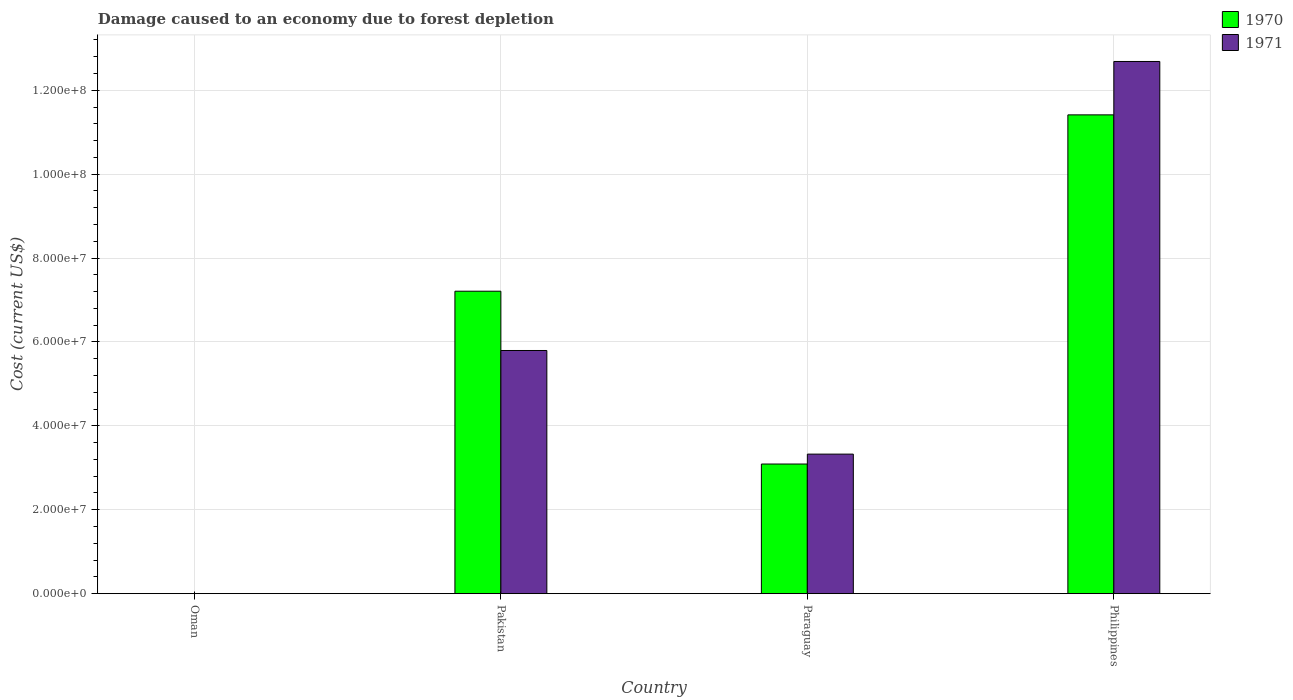Are the number of bars per tick equal to the number of legend labels?
Your answer should be compact. Yes. Are the number of bars on each tick of the X-axis equal?
Make the answer very short. Yes. What is the cost of damage caused due to forest depletion in 1970 in Pakistan?
Offer a very short reply. 7.21e+07. Across all countries, what is the maximum cost of damage caused due to forest depletion in 1970?
Keep it short and to the point. 1.14e+08. Across all countries, what is the minimum cost of damage caused due to forest depletion in 1971?
Offer a very short reply. 2.65e+04. In which country was the cost of damage caused due to forest depletion in 1971 maximum?
Offer a very short reply. Philippines. In which country was the cost of damage caused due to forest depletion in 1970 minimum?
Your answer should be compact. Oman. What is the total cost of damage caused due to forest depletion in 1970 in the graph?
Ensure brevity in your answer.  2.17e+08. What is the difference between the cost of damage caused due to forest depletion in 1971 in Pakistan and that in Paraguay?
Offer a terse response. 2.47e+07. What is the difference between the cost of damage caused due to forest depletion in 1970 in Pakistan and the cost of damage caused due to forest depletion in 1971 in Philippines?
Your response must be concise. -5.48e+07. What is the average cost of damage caused due to forest depletion in 1970 per country?
Give a very brief answer. 5.43e+07. What is the difference between the cost of damage caused due to forest depletion of/in 1970 and cost of damage caused due to forest depletion of/in 1971 in Oman?
Your answer should be very brief. 6781.75. What is the ratio of the cost of damage caused due to forest depletion in 1970 in Paraguay to that in Philippines?
Your answer should be very brief. 0.27. Is the cost of damage caused due to forest depletion in 1971 in Pakistan less than that in Paraguay?
Give a very brief answer. No. What is the difference between the highest and the second highest cost of damage caused due to forest depletion in 1971?
Your answer should be very brief. -2.47e+07. What is the difference between the highest and the lowest cost of damage caused due to forest depletion in 1970?
Offer a terse response. 1.14e+08. In how many countries, is the cost of damage caused due to forest depletion in 1970 greater than the average cost of damage caused due to forest depletion in 1970 taken over all countries?
Provide a short and direct response. 2. What does the 2nd bar from the left in Pakistan represents?
Your answer should be compact. 1971. What is the difference between two consecutive major ticks on the Y-axis?
Make the answer very short. 2.00e+07. Are the values on the major ticks of Y-axis written in scientific E-notation?
Provide a succinct answer. Yes. What is the title of the graph?
Make the answer very short. Damage caused to an economy due to forest depletion. What is the label or title of the X-axis?
Provide a short and direct response. Country. What is the label or title of the Y-axis?
Ensure brevity in your answer.  Cost (current US$). What is the Cost (current US$) of 1970 in Oman?
Your response must be concise. 3.33e+04. What is the Cost (current US$) of 1971 in Oman?
Your response must be concise. 2.65e+04. What is the Cost (current US$) of 1970 in Pakistan?
Make the answer very short. 7.21e+07. What is the Cost (current US$) of 1971 in Pakistan?
Ensure brevity in your answer.  5.80e+07. What is the Cost (current US$) of 1970 in Paraguay?
Provide a succinct answer. 3.09e+07. What is the Cost (current US$) in 1971 in Paraguay?
Provide a short and direct response. 3.33e+07. What is the Cost (current US$) in 1970 in Philippines?
Provide a succinct answer. 1.14e+08. What is the Cost (current US$) in 1971 in Philippines?
Keep it short and to the point. 1.27e+08. Across all countries, what is the maximum Cost (current US$) in 1970?
Offer a terse response. 1.14e+08. Across all countries, what is the maximum Cost (current US$) in 1971?
Provide a short and direct response. 1.27e+08. Across all countries, what is the minimum Cost (current US$) in 1970?
Ensure brevity in your answer.  3.33e+04. Across all countries, what is the minimum Cost (current US$) of 1971?
Keep it short and to the point. 2.65e+04. What is the total Cost (current US$) in 1970 in the graph?
Your response must be concise. 2.17e+08. What is the total Cost (current US$) of 1971 in the graph?
Your response must be concise. 2.18e+08. What is the difference between the Cost (current US$) in 1970 in Oman and that in Pakistan?
Offer a terse response. -7.21e+07. What is the difference between the Cost (current US$) in 1971 in Oman and that in Pakistan?
Your answer should be compact. -5.79e+07. What is the difference between the Cost (current US$) of 1970 in Oman and that in Paraguay?
Your answer should be very brief. -3.09e+07. What is the difference between the Cost (current US$) in 1971 in Oman and that in Paraguay?
Give a very brief answer. -3.32e+07. What is the difference between the Cost (current US$) of 1970 in Oman and that in Philippines?
Your answer should be compact. -1.14e+08. What is the difference between the Cost (current US$) in 1971 in Oman and that in Philippines?
Make the answer very short. -1.27e+08. What is the difference between the Cost (current US$) in 1970 in Pakistan and that in Paraguay?
Your answer should be compact. 4.12e+07. What is the difference between the Cost (current US$) in 1971 in Pakistan and that in Paraguay?
Ensure brevity in your answer.  2.47e+07. What is the difference between the Cost (current US$) of 1970 in Pakistan and that in Philippines?
Provide a succinct answer. -4.20e+07. What is the difference between the Cost (current US$) in 1971 in Pakistan and that in Philippines?
Your response must be concise. -6.89e+07. What is the difference between the Cost (current US$) of 1970 in Paraguay and that in Philippines?
Your answer should be very brief. -8.32e+07. What is the difference between the Cost (current US$) of 1971 in Paraguay and that in Philippines?
Make the answer very short. -9.36e+07. What is the difference between the Cost (current US$) of 1970 in Oman and the Cost (current US$) of 1971 in Pakistan?
Offer a terse response. -5.79e+07. What is the difference between the Cost (current US$) in 1970 in Oman and the Cost (current US$) in 1971 in Paraguay?
Provide a short and direct response. -3.32e+07. What is the difference between the Cost (current US$) in 1970 in Oman and the Cost (current US$) in 1971 in Philippines?
Offer a terse response. -1.27e+08. What is the difference between the Cost (current US$) of 1970 in Pakistan and the Cost (current US$) of 1971 in Paraguay?
Ensure brevity in your answer.  3.88e+07. What is the difference between the Cost (current US$) in 1970 in Pakistan and the Cost (current US$) in 1971 in Philippines?
Provide a succinct answer. -5.48e+07. What is the difference between the Cost (current US$) of 1970 in Paraguay and the Cost (current US$) of 1971 in Philippines?
Ensure brevity in your answer.  -9.60e+07. What is the average Cost (current US$) in 1970 per country?
Keep it short and to the point. 5.43e+07. What is the average Cost (current US$) of 1971 per country?
Your answer should be compact. 5.45e+07. What is the difference between the Cost (current US$) in 1970 and Cost (current US$) in 1971 in Oman?
Offer a terse response. 6781.75. What is the difference between the Cost (current US$) of 1970 and Cost (current US$) of 1971 in Pakistan?
Offer a very short reply. 1.41e+07. What is the difference between the Cost (current US$) of 1970 and Cost (current US$) of 1971 in Paraguay?
Make the answer very short. -2.36e+06. What is the difference between the Cost (current US$) in 1970 and Cost (current US$) in 1971 in Philippines?
Give a very brief answer. -1.27e+07. What is the ratio of the Cost (current US$) of 1971 in Oman to that in Pakistan?
Keep it short and to the point. 0. What is the ratio of the Cost (current US$) of 1970 in Oman to that in Paraguay?
Ensure brevity in your answer.  0. What is the ratio of the Cost (current US$) of 1971 in Oman to that in Paraguay?
Your response must be concise. 0. What is the ratio of the Cost (current US$) in 1971 in Oman to that in Philippines?
Your answer should be very brief. 0. What is the ratio of the Cost (current US$) in 1970 in Pakistan to that in Paraguay?
Your answer should be very brief. 2.33. What is the ratio of the Cost (current US$) of 1971 in Pakistan to that in Paraguay?
Provide a succinct answer. 1.74. What is the ratio of the Cost (current US$) in 1970 in Pakistan to that in Philippines?
Your response must be concise. 0.63. What is the ratio of the Cost (current US$) in 1971 in Pakistan to that in Philippines?
Offer a terse response. 0.46. What is the ratio of the Cost (current US$) of 1970 in Paraguay to that in Philippines?
Offer a terse response. 0.27. What is the ratio of the Cost (current US$) in 1971 in Paraguay to that in Philippines?
Provide a short and direct response. 0.26. What is the difference between the highest and the second highest Cost (current US$) of 1970?
Offer a very short reply. 4.20e+07. What is the difference between the highest and the second highest Cost (current US$) of 1971?
Make the answer very short. 6.89e+07. What is the difference between the highest and the lowest Cost (current US$) of 1970?
Provide a succinct answer. 1.14e+08. What is the difference between the highest and the lowest Cost (current US$) in 1971?
Provide a succinct answer. 1.27e+08. 